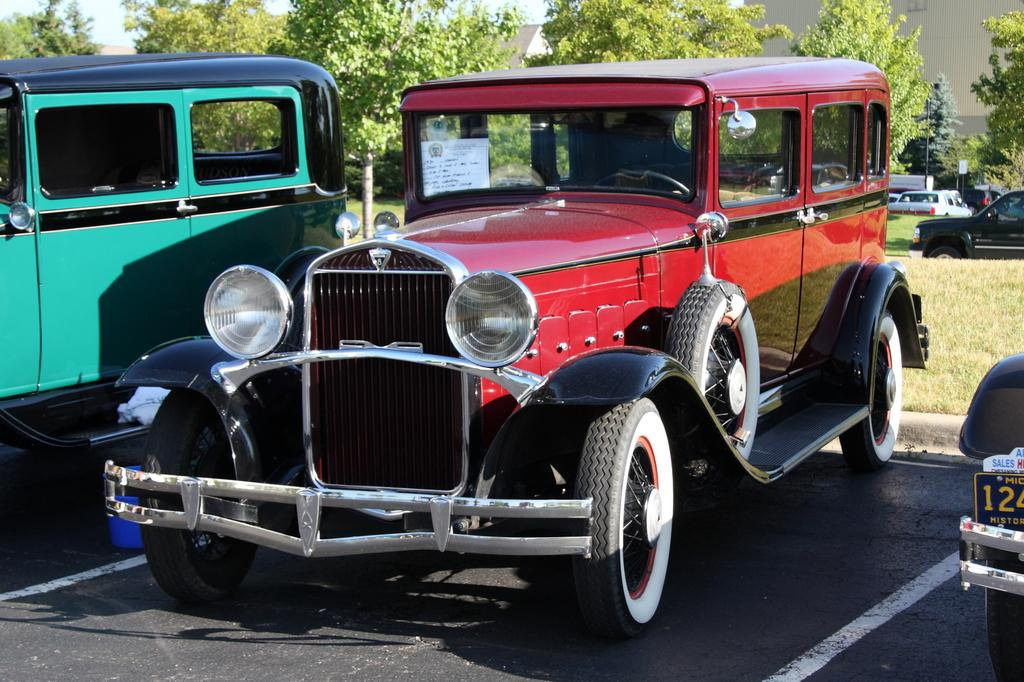What can be seen on the road in the image? There are cars on the road in the image. What type of natural environment is visible in the background of the image? There are trees and grass present in the background of the image. What type of structures can be seen in the background of the image? There are houses in the background of the image. Are there any other cars visible in the image besides those on the road? Yes, there are cars visible in the background of the image. Where is the throne located in the image? There is no throne present in the image. What hobbies are the people in the image engaged in? The image does not show any people, so their hobbies cannot be determined. 